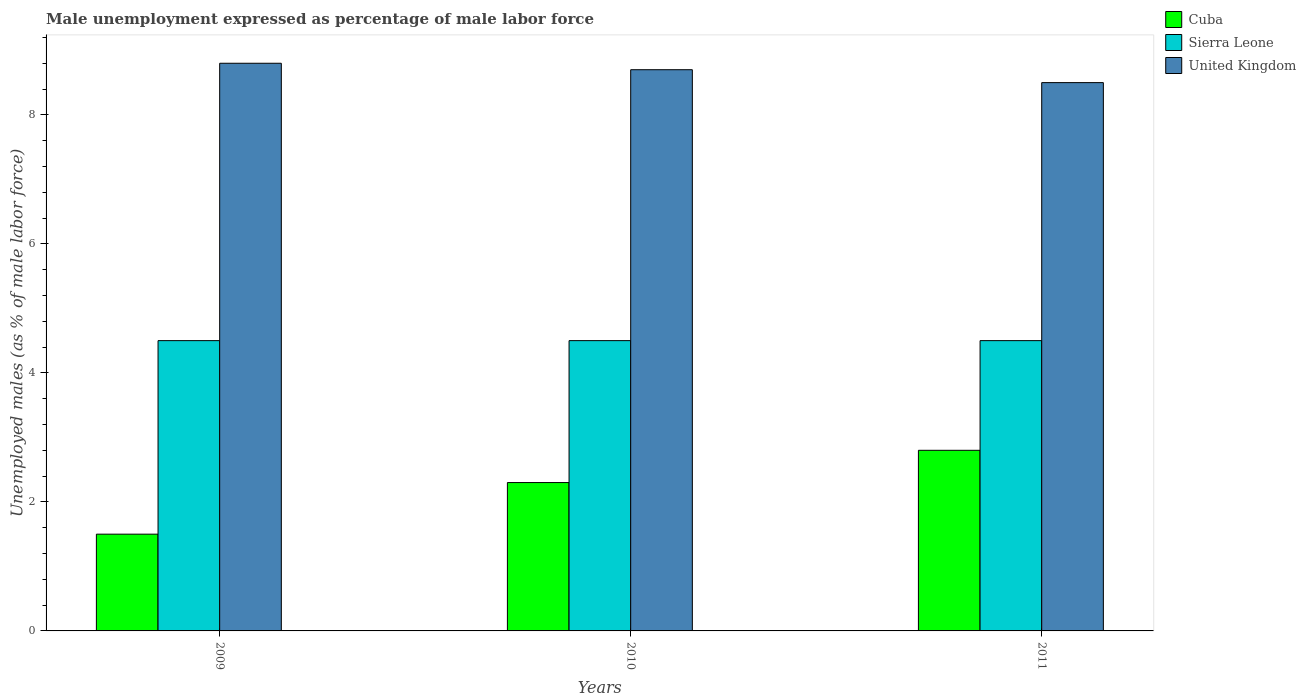How many different coloured bars are there?
Your response must be concise. 3. How many groups of bars are there?
Your response must be concise. 3. Are the number of bars per tick equal to the number of legend labels?
Offer a very short reply. Yes. Are the number of bars on each tick of the X-axis equal?
Provide a succinct answer. Yes. How many bars are there on the 2nd tick from the left?
Your response must be concise. 3. Across all years, what is the maximum unemployment in males in in United Kingdom?
Provide a succinct answer. 8.8. Across all years, what is the minimum unemployment in males in in Cuba?
Keep it short and to the point. 1.5. In which year was the unemployment in males in in United Kingdom maximum?
Ensure brevity in your answer.  2009. In which year was the unemployment in males in in Sierra Leone minimum?
Keep it short and to the point. 2009. What is the difference between the unemployment in males in in Cuba in 2011 and the unemployment in males in in United Kingdom in 2010?
Your answer should be very brief. -5.9. What is the average unemployment in males in in Cuba per year?
Offer a terse response. 2.2. In the year 2010, what is the difference between the unemployment in males in in United Kingdom and unemployment in males in in Sierra Leone?
Your answer should be very brief. 4.2. What is the ratio of the unemployment in males in in Cuba in 2010 to that in 2011?
Keep it short and to the point. 0.82. Is the unemployment in males in in Cuba in 2010 less than that in 2011?
Offer a terse response. Yes. What is the difference between the highest and the second highest unemployment in males in in Cuba?
Your answer should be very brief. 0.5. In how many years, is the unemployment in males in in Cuba greater than the average unemployment in males in in Cuba taken over all years?
Keep it short and to the point. 2. Is the sum of the unemployment in males in in Sierra Leone in 2010 and 2011 greater than the maximum unemployment in males in in United Kingdom across all years?
Your answer should be very brief. Yes. What does the 3rd bar from the right in 2011 represents?
Your response must be concise. Cuba. How many bars are there?
Keep it short and to the point. 9. Are the values on the major ticks of Y-axis written in scientific E-notation?
Provide a succinct answer. No. Does the graph contain any zero values?
Offer a very short reply. No. Does the graph contain grids?
Your answer should be compact. No. How many legend labels are there?
Keep it short and to the point. 3. How are the legend labels stacked?
Make the answer very short. Vertical. What is the title of the graph?
Provide a short and direct response. Male unemployment expressed as percentage of male labor force. Does "Brunei Darussalam" appear as one of the legend labels in the graph?
Offer a very short reply. No. What is the label or title of the Y-axis?
Keep it short and to the point. Unemployed males (as % of male labor force). What is the Unemployed males (as % of male labor force) of United Kingdom in 2009?
Offer a terse response. 8.8. What is the Unemployed males (as % of male labor force) of Cuba in 2010?
Give a very brief answer. 2.3. What is the Unemployed males (as % of male labor force) of Sierra Leone in 2010?
Your answer should be compact. 4.5. What is the Unemployed males (as % of male labor force) in United Kingdom in 2010?
Your response must be concise. 8.7. What is the Unemployed males (as % of male labor force) of Cuba in 2011?
Provide a succinct answer. 2.8. Across all years, what is the maximum Unemployed males (as % of male labor force) of Cuba?
Ensure brevity in your answer.  2.8. Across all years, what is the maximum Unemployed males (as % of male labor force) of Sierra Leone?
Offer a terse response. 4.5. Across all years, what is the maximum Unemployed males (as % of male labor force) of United Kingdom?
Provide a succinct answer. 8.8. Across all years, what is the minimum Unemployed males (as % of male labor force) in Sierra Leone?
Offer a very short reply. 4.5. Across all years, what is the minimum Unemployed males (as % of male labor force) in United Kingdom?
Your response must be concise. 8.5. What is the total Unemployed males (as % of male labor force) of Cuba in the graph?
Give a very brief answer. 6.6. What is the total Unemployed males (as % of male labor force) of Sierra Leone in the graph?
Keep it short and to the point. 13.5. What is the total Unemployed males (as % of male labor force) in United Kingdom in the graph?
Offer a very short reply. 26. What is the difference between the Unemployed males (as % of male labor force) of Cuba in 2009 and that in 2010?
Give a very brief answer. -0.8. What is the difference between the Unemployed males (as % of male labor force) of United Kingdom in 2009 and that in 2011?
Offer a terse response. 0.3. What is the difference between the Unemployed males (as % of male labor force) of Cuba in 2010 and that in 2011?
Your answer should be compact. -0.5. What is the difference between the Unemployed males (as % of male labor force) of Sierra Leone in 2010 and that in 2011?
Provide a short and direct response. 0. What is the difference between the Unemployed males (as % of male labor force) of Cuba in 2009 and the Unemployed males (as % of male labor force) of Sierra Leone in 2010?
Ensure brevity in your answer.  -3. What is the difference between the Unemployed males (as % of male labor force) of Sierra Leone in 2009 and the Unemployed males (as % of male labor force) of United Kingdom in 2011?
Your response must be concise. -4. What is the difference between the Unemployed males (as % of male labor force) in Sierra Leone in 2010 and the Unemployed males (as % of male labor force) in United Kingdom in 2011?
Offer a very short reply. -4. What is the average Unemployed males (as % of male labor force) of Cuba per year?
Your response must be concise. 2.2. What is the average Unemployed males (as % of male labor force) of Sierra Leone per year?
Offer a very short reply. 4.5. What is the average Unemployed males (as % of male labor force) in United Kingdom per year?
Keep it short and to the point. 8.67. In the year 2009, what is the difference between the Unemployed males (as % of male labor force) of Sierra Leone and Unemployed males (as % of male labor force) of United Kingdom?
Ensure brevity in your answer.  -4.3. In the year 2010, what is the difference between the Unemployed males (as % of male labor force) in Cuba and Unemployed males (as % of male labor force) in Sierra Leone?
Ensure brevity in your answer.  -2.2. In the year 2010, what is the difference between the Unemployed males (as % of male labor force) of Cuba and Unemployed males (as % of male labor force) of United Kingdom?
Ensure brevity in your answer.  -6.4. In the year 2010, what is the difference between the Unemployed males (as % of male labor force) of Sierra Leone and Unemployed males (as % of male labor force) of United Kingdom?
Ensure brevity in your answer.  -4.2. In the year 2011, what is the difference between the Unemployed males (as % of male labor force) of Cuba and Unemployed males (as % of male labor force) of United Kingdom?
Offer a very short reply. -5.7. What is the ratio of the Unemployed males (as % of male labor force) of Cuba in 2009 to that in 2010?
Your answer should be very brief. 0.65. What is the ratio of the Unemployed males (as % of male labor force) in Sierra Leone in 2009 to that in 2010?
Your answer should be compact. 1. What is the ratio of the Unemployed males (as % of male labor force) of United Kingdom in 2009 to that in 2010?
Give a very brief answer. 1.01. What is the ratio of the Unemployed males (as % of male labor force) in Cuba in 2009 to that in 2011?
Make the answer very short. 0.54. What is the ratio of the Unemployed males (as % of male labor force) in United Kingdom in 2009 to that in 2011?
Your response must be concise. 1.04. What is the ratio of the Unemployed males (as % of male labor force) in Cuba in 2010 to that in 2011?
Provide a short and direct response. 0.82. What is the ratio of the Unemployed males (as % of male labor force) in Sierra Leone in 2010 to that in 2011?
Your response must be concise. 1. What is the ratio of the Unemployed males (as % of male labor force) of United Kingdom in 2010 to that in 2011?
Your answer should be very brief. 1.02. What is the difference between the highest and the second highest Unemployed males (as % of male labor force) of Cuba?
Keep it short and to the point. 0.5. What is the difference between the highest and the lowest Unemployed males (as % of male labor force) in United Kingdom?
Provide a short and direct response. 0.3. 